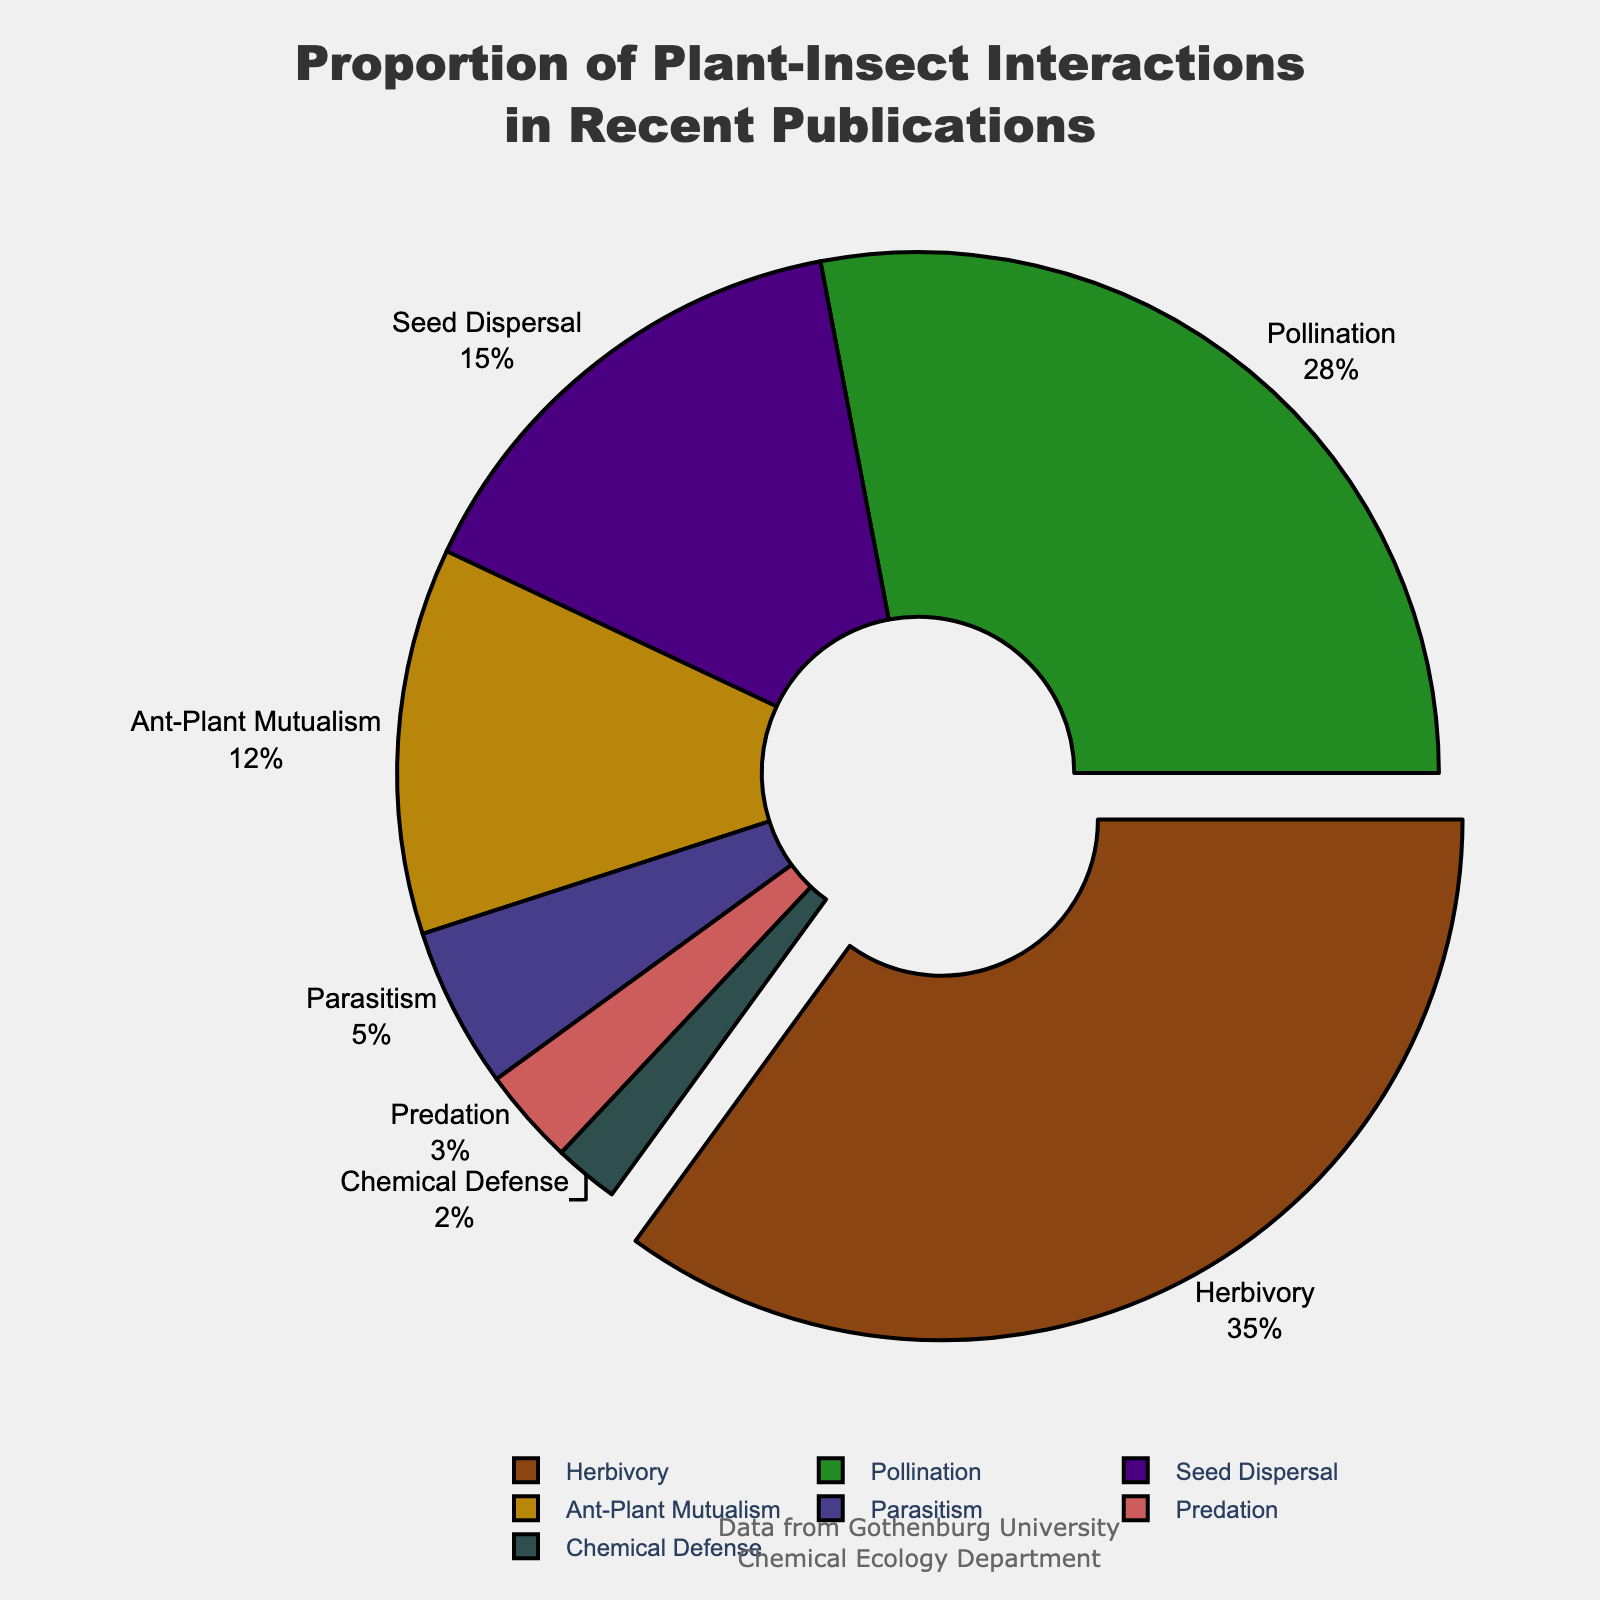What is the proportion of herbivory studies in the department's recent publications? Identify the section labeled 'Herbivory' and read its proportion directly from the chart. The chart indicates that herbivory accounts for 35%.
Answer: 35% Which type of plant-insect interaction has the smallest proportion of studies? Locate the section with the smallest percentage label. The chart shows that 'Chemical Defense' has the smallest proportion at 2%.
Answer: Chemical Defense What is the combined proportion of studies on seed dispersal and ant-plant mutualism? Find the proportions for 'Seed Dispersal' (15%) and 'Ant-Plant Mutualism' (12%) and add them together: 15% + 12% = 27%.
Answer: 27% How does the proportion of parasitism studies compare to predation studies? Compare the proportions given for 'Parasitism' (5%) and 'Predation' (3%). The proportion of parasitism studies is greater than predation studies by 2%.
Answer: Parasitism is greater Which interaction type has a proportion close to 30%? Locate any section with a proportion around 30%. The chart indicates that 'Pollination' has a proportion of 28%, which is the closest to 30%.
Answer: Pollination What is the difference in proportion between herbivory and pollination studies? Find the proportions for 'Herbivory' (35%) and 'Pollination' (28%), then subtract the latter from the former: 35% - 28% = 7%.
Answer: 7% Which plant-insect interaction type is highlighted (pulled out) in the pie chart? Observe the visual element where one section is slightly pulled out. The chart has 'Herbivory' highlighted, which is the section with the highest proportion (35%).
Answer: Herbivory What proportion of studies focus on mutualistic relationships (Ant-Plant Mutualism and Pollination together)? Find and sum the proportions for 'Ant-Plant Mutualism' (12%) and 'Pollination' (28%): 12% + 28% = 40%.
Answer: 40% Is the proportion of pollination studies greater than the sum of parasitism and predation studies? Compare the proportion of 'Pollination' (28%) with the sum of 'Parasitism' (5%) and 'Predation' (3%). Sum them up: 5% + 3% = 8%. Since 28% > 8%, the answer is yes.
Answer: Yes What are the top three plant-insect interactions in terms of study proportions? Identify the three largest sections in the chart, which are 'Herbivory' (35%), 'Pollination' (28%), and 'Seed Dispersal' (15%).
Answer: Herbivory, Pollination, Seed Dispersal 